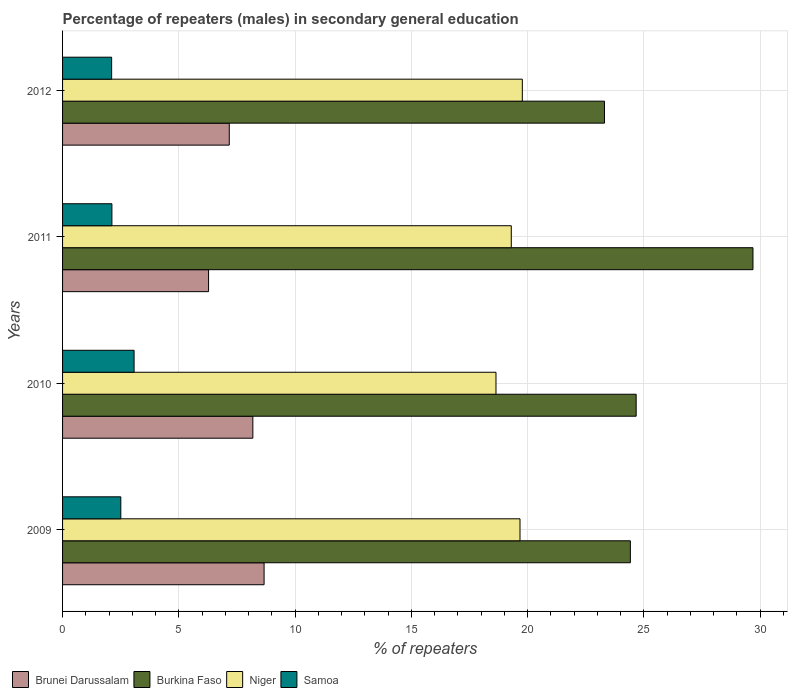Are the number of bars per tick equal to the number of legend labels?
Your response must be concise. Yes. How many bars are there on the 3rd tick from the top?
Ensure brevity in your answer.  4. What is the percentage of male repeaters in Brunei Darussalam in 2010?
Your answer should be compact. 8.18. Across all years, what is the maximum percentage of male repeaters in Brunei Darussalam?
Offer a terse response. 8.67. Across all years, what is the minimum percentage of male repeaters in Niger?
Offer a very short reply. 18.64. In which year was the percentage of male repeaters in Niger minimum?
Offer a terse response. 2010. What is the total percentage of male repeaters in Burkina Faso in the graph?
Give a very brief answer. 102.08. What is the difference between the percentage of male repeaters in Burkina Faso in 2011 and that in 2012?
Offer a very short reply. 6.39. What is the difference between the percentage of male repeaters in Brunei Darussalam in 2011 and the percentage of male repeaters in Burkina Faso in 2012?
Offer a terse response. -17.03. What is the average percentage of male repeaters in Brunei Darussalam per year?
Provide a succinct answer. 7.57. In the year 2009, what is the difference between the percentage of male repeaters in Samoa and percentage of male repeaters in Burkina Faso?
Your answer should be compact. -21.91. What is the ratio of the percentage of male repeaters in Brunei Darussalam in 2010 to that in 2012?
Your answer should be very brief. 1.14. Is the percentage of male repeaters in Burkina Faso in 2009 less than that in 2012?
Provide a succinct answer. No. Is the difference between the percentage of male repeaters in Samoa in 2009 and 2011 greater than the difference between the percentage of male repeaters in Burkina Faso in 2009 and 2011?
Your answer should be very brief. Yes. What is the difference between the highest and the second highest percentage of male repeaters in Niger?
Ensure brevity in your answer.  0.1. What is the difference between the highest and the lowest percentage of male repeaters in Niger?
Provide a succinct answer. 1.13. What does the 2nd bar from the top in 2012 represents?
Give a very brief answer. Niger. What does the 4th bar from the bottom in 2010 represents?
Offer a terse response. Samoa. Is it the case that in every year, the sum of the percentage of male repeaters in Burkina Faso and percentage of male repeaters in Samoa is greater than the percentage of male repeaters in Niger?
Offer a very short reply. Yes. How many bars are there?
Your answer should be very brief. 16. Are all the bars in the graph horizontal?
Provide a succinct answer. Yes. How many years are there in the graph?
Provide a succinct answer. 4. What is the difference between two consecutive major ticks on the X-axis?
Make the answer very short. 5. Does the graph contain any zero values?
Keep it short and to the point. No. Does the graph contain grids?
Ensure brevity in your answer.  Yes. How many legend labels are there?
Offer a very short reply. 4. What is the title of the graph?
Offer a very short reply. Percentage of repeaters (males) in secondary general education. What is the label or title of the X-axis?
Give a very brief answer. % of repeaters. What is the % of repeaters of Brunei Darussalam in 2009?
Offer a very short reply. 8.67. What is the % of repeaters in Burkina Faso in 2009?
Your response must be concise. 24.42. What is the % of repeaters in Niger in 2009?
Your answer should be very brief. 19.67. What is the % of repeaters of Samoa in 2009?
Your answer should be very brief. 2.51. What is the % of repeaters of Brunei Darussalam in 2010?
Keep it short and to the point. 8.18. What is the % of repeaters of Burkina Faso in 2010?
Ensure brevity in your answer.  24.67. What is the % of repeaters of Niger in 2010?
Make the answer very short. 18.64. What is the % of repeaters of Samoa in 2010?
Your response must be concise. 3.08. What is the % of repeaters in Brunei Darussalam in 2011?
Ensure brevity in your answer.  6.28. What is the % of repeaters in Burkina Faso in 2011?
Provide a succinct answer. 29.69. What is the % of repeaters in Niger in 2011?
Your answer should be compact. 19.3. What is the % of repeaters of Samoa in 2011?
Your answer should be compact. 2.12. What is the % of repeaters in Brunei Darussalam in 2012?
Your response must be concise. 7.17. What is the % of repeaters in Burkina Faso in 2012?
Provide a succinct answer. 23.3. What is the % of repeaters of Niger in 2012?
Make the answer very short. 19.77. What is the % of repeaters of Samoa in 2012?
Your answer should be very brief. 2.11. Across all years, what is the maximum % of repeaters in Brunei Darussalam?
Keep it short and to the point. 8.67. Across all years, what is the maximum % of repeaters in Burkina Faso?
Provide a succinct answer. 29.69. Across all years, what is the maximum % of repeaters in Niger?
Your response must be concise. 19.77. Across all years, what is the maximum % of repeaters in Samoa?
Offer a very short reply. 3.08. Across all years, what is the minimum % of repeaters of Brunei Darussalam?
Keep it short and to the point. 6.28. Across all years, what is the minimum % of repeaters of Burkina Faso?
Your response must be concise. 23.3. Across all years, what is the minimum % of repeaters of Niger?
Your answer should be very brief. 18.64. Across all years, what is the minimum % of repeaters in Samoa?
Offer a terse response. 2.11. What is the total % of repeaters of Brunei Darussalam in the graph?
Your answer should be very brief. 30.3. What is the total % of repeaters of Burkina Faso in the graph?
Your answer should be compact. 102.08. What is the total % of repeaters in Niger in the graph?
Give a very brief answer. 77.38. What is the total % of repeaters in Samoa in the graph?
Your answer should be compact. 9.81. What is the difference between the % of repeaters in Brunei Darussalam in 2009 and that in 2010?
Ensure brevity in your answer.  0.48. What is the difference between the % of repeaters in Burkina Faso in 2009 and that in 2010?
Give a very brief answer. -0.25. What is the difference between the % of repeaters of Niger in 2009 and that in 2010?
Your answer should be compact. 1.03. What is the difference between the % of repeaters in Samoa in 2009 and that in 2010?
Give a very brief answer. -0.57. What is the difference between the % of repeaters of Brunei Darussalam in 2009 and that in 2011?
Keep it short and to the point. 2.39. What is the difference between the % of repeaters of Burkina Faso in 2009 and that in 2011?
Make the answer very short. -5.27. What is the difference between the % of repeaters in Samoa in 2009 and that in 2011?
Offer a terse response. 0.38. What is the difference between the % of repeaters of Brunei Darussalam in 2009 and that in 2012?
Make the answer very short. 1.5. What is the difference between the % of repeaters of Burkina Faso in 2009 and that in 2012?
Offer a very short reply. 1.11. What is the difference between the % of repeaters of Niger in 2009 and that in 2012?
Provide a short and direct response. -0.1. What is the difference between the % of repeaters in Samoa in 2009 and that in 2012?
Your answer should be compact. 0.39. What is the difference between the % of repeaters of Brunei Darussalam in 2010 and that in 2011?
Keep it short and to the point. 1.9. What is the difference between the % of repeaters of Burkina Faso in 2010 and that in 2011?
Your answer should be compact. -5.02. What is the difference between the % of repeaters of Niger in 2010 and that in 2011?
Your answer should be very brief. -0.66. What is the difference between the % of repeaters in Samoa in 2010 and that in 2011?
Offer a very short reply. 0.95. What is the difference between the % of repeaters in Brunei Darussalam in 2010 and that in 2012?
Make the answer very short. 1.01. What is the difference between the % of repeaters in Burkina Faso in 2010 and that in 2012?
Offer a terse response. 1.36. What is the difference between the % of repeaters of Niger in 2010 and that in 2012?
Give a very brief answer. -1.13. What is the difference between the % of repeaters of Samoa in 2010 and that in 2012?
Offer a very short reply. 0.96. What is the difference between the % of repeaters in Brunei Darussalam in 2011 and that in 2012?
Your response must be concise. -0.89. What is the difference between the % of repeaters of Burkina Faso in 2011 and that in 2012?
Ensure brevity in your answer.  6.39. What is the difference between the % of repeaters of Niger in 2011 and that in 2012?
Offer a very short reply. -0.47. What is the difference between the % of repeaters in Samoa in 2011 and that in 2012?
Your answer should be compact. 0.01. What is the difference between the % of repeaters in Brunei Darussalam in 2009 and the % of repeaters in Burkina Faso in 2010?
Offer a terse response. -16. What is the difference between the % of repeaters of Brunei Darussalam in 2009 and the % of repeaters of Niger in 2010?
Provide a short and direct response. -9.97. What is the difference between the % of repeaters in Brunei Darussalam in 2009 and the % of repeaters in Samoa in 2010?
Your answer should be very brief. 5.59. What is the difference between the % of repeaters of Burkina Faso in 2009 and the % of repeaters of Niger in 2010?
Offer a very short reply. 5.78. What is the difference between the % of repeaters of Burkina Faso in 2009 and the % of repeaters of Samoa in 2010?
Keep it short and to the point. 21.34. What is the difference between the % of repeaters of Niger in 2009 and the % of repeaters of Samoa in 2010?
Give a very brief answer. 16.6. What is the difference between the % of repeaters of Brunei Darussalam in 2009 and the % of repeaters of Burkina Faso in 2011?
Give a very brief answer. -21.02. What is the difference between the % of repeaters in Brunei Darussalam in 2009 and the % of repeaters in Niger in 2011?
Offer a very short reply. -10.63. What is the difference between the % of repeaters of Brunei Darussalam in 2009 and the % of repeaters of Samoa in 2011?
Make the answer very short. 6.54. What is the difference between the % of repeaters in Burkina Faso in 2009 and the % of repeaters in Niger in 2011?
Provide a short and direct response. 5.12. What is the difference between the % of repeaters of Burkina Faso in 2009 and the % of repeaters of Samoa in 2011?
Offer a very short reply. 22.3. What is the difference between the % of repeaters of Niger in 2009 and the % of repeaters of Samoa in 2011?
Offer a terse response. 17.55. What is the difference between the % of repeaters in Brunei Darussalam in 2009 and the % of repeaters in Burkina Faso in 2012?
Ensure brevity in your answer.  -14.64. What is the difference between the % of repeaters of Brunei Darussalam in 2009 and the % of repeaters of Niger in 2012?
Your answer should be very brief. -11.11. What is the difference between the % of repeaters of Brunei Darussalam in 2009 and the % of repeaters of Samoa in 2012?
Your answer should be compact. 6.56. What is the difference between the % of repeaters in Burkina Faso in 2009 and the % of repeaters in Niger in 2012?
Provide a short and direct response. 4.65. What is the difference between the % of repeaters in Burkina Faso in 2009 and the % of repeaters in Samoa in 2012?
Offer a very short reply. 22.31. What is the difference between the % of repeaters of Niger in 2009 and the % of repeaters of Samoa in 2012?
Offer a terse response. 17.56. What is the difference between the % of repeaters in Brunei Darussalam in 2010 and the % of repeaters in Burkina Faso in 2011?
Give a very brief answer. -21.51. What is the difference between the % of repeaters in Brunei Darussalam in 2010 and the % of repeaters in Niger in 2011?
Keep it short and to the point. -11.11. What is the difference between the % of repeaters of Brunei Darussalam in 2010 and the % of repeaters of Samoa in 2011?
Your response must be concise. 6.06. What is the difference between the % of repeaters of Burkina Faso in 2010 and the % of repeaters of Niger in 2011?
Keep it short and to the point. 5.37. What is the difference between the % of repeaters of Burkina Faso in 2010 and the % of repeaters of Samoa in 2011?
Your answer should be very brief. 22.55. What is the difference between the % of repeaters of Niger in 2010 and the % of repeaters of Samoa in 2011?
Your answer should be compact. 16.52. What is the difference between the % of repeaters of Brunei Darussalam in 2010 and the % of repeaters of Burkina Faso in 2012?
Make the answer very short. -15.12. What is the difference between the % of repeaters in Brunei Darussalam in 2010 and the % of repeaters in Niger in 2012?
Provide a succinct answer. -11.59. What is the difference between the % of repeaters of Brunei Darussalam in 2010 and the % of repeaters of Samoa in 2012?
Your answer should be compact. 6.07. What is the difference between the % of repeaters in Burkina Faso in 2010 and the % of repeaters in Niger in 2012?
Provide a succinct answer. 4.9. What is the difference between the % of repeaters of Burkina Faso in 2010 and the % of repeaters of Samoa in 2012?
Ensure brevity in your answer.  22.56. What is the difference between the % of repeaters of Niger in 2010 and the % of repeaters of Samoa in 2012?
Offer a very short reply. 16.53. What is the difference between the % of repeaters of Brunei Darussalam in 2011 and the % of repeaters of Burkina Faso in 2012?
Provide a short and direct response. -17.03. What is the difference between the % of repeaters in Brunei Darussalam in 2011 and the % of repeaters in Niger in 2012?
Keep it short and to the point. -13.49. What is the difference between the % of repeaters of Brunei Darussalam in 2011 and the % of repeaters of Samoa in 2012?
Provide a short and direct response. 4.17. What is the difference between the % of repeaters of Burkina Faso in 2011 and the % of repeaters of Niger in 2012?
Make the answer very short. 9.92. What is the difference between the % of repeaters of Burkina Faso in 2011 and the % of repeaters of Samoa in 2012?
Your answer should be compact. 27.58. What is the difference between the % of repeaters of Niger in 2011 and the % of repeaters of Samoa in 2012?
Your answer should be compact. 17.19. What is the average % of repeaters in Brunei Darussalam per year?
Offer a terse response. 7.57. What is the average % of repeaters in Burkina Faso per year?
Provide a short and direct response. 25.52. What is the average % of repeaters in Niger per year?
Give a very brief answer. 19.35. What is the average % of repeaters of Samoa per year?
Ensure brevity in your answer.  2.45. In the year 2009, what is the difference between the % of repeaters of Brunei Darussalam and % of repeaters of Burkina Faso?
Ensure brevity in your answer.  -15.75. In the year 2009, what is the difference between the % of repeaters in Brunei Darussalam and % of repeaters in Niger?
Keep it short and to the point. -11.01. In the year 2009, what is the difference between the % of repeaters in Brunei Darussalam and % of repeaters in Samoa?
Make the answer very short. 6.16. In the year 2009, what is the difference between the % of repeaters of Burkina Faso and % of repeaters of Niger?
Your answer should be compact. 4.75. In the year 2009, what is the difference between the % of repeaters in Burkina Faso and % of repeaters in Samoa?
Make the answer very short. 21.91. In the year 2009, what is the difference between the % of repeaters of Niger and % of repeaters of Samoa?
Offer a terse response. 17.17. In the year 2010, what is the difference between the % of repeaters of Brunei Darussalam and % of repeaters of Burkina Faso?
Provide a succinct answer. -16.48. In the year 2010, what is the difference between the % of repeaters of Brunei Darussalam and % of repeaters of Niger?
Give a very brief answer. -10.46. In the year 2010, what is the difference between the % of repeaters of Brunei Darussalam and % of repeaters of Samoa?
Make the answer very short. 5.11. In the year 2010, what is the difference between the % of repeaters in Burkina Faso and % of repeaters in Niger?
Your answer should be compact. 6.03. In the year 2010, what is the difference between the % of repeaters in Burkina Faso and % of repeaters in Samoa?
Offer a very short reply. 21.59. In the year 2010, what is the difference between the % of repeaters in Niger and % of repeaters in Samoa?
Give a very brief answer. 15.56. In the year 2011, what is the difference between the % of repeaters of Brunei Darussalam and % of repeaters of Burkina Faso?
Your answer should be compact. -23.41. In the year 2011, what is the difference between the % of repeaters in Brunei Darussalam and % of repeaters in Niger?
Give a very brief answer. -13.02. In the year 2011, what is the difference between the % of repeaters in Brunei Darussalam and % of repeaters in Samoa?
Keep it short and to the point. 4.16. In the year 2011, what is the difference between the % of repeaters in Burkina Faso and % of repeaters in Niger?
Your response must be concise. 10.39. In the year 2011, what is the difference between the % of repeaters in Burkina Faso and % of repeaters in Samoa?
Offer a terse response. 27.57. In the year 2011, what is the difference between the % of repeaters of Niger and % of repeaters of Samoa?
Your response must be concise. 17.18. In the year 2012, what is the difference between the % of repeaters in Brunei Darussalam and % of repeaters in Burkina Faso?
Your answer should be compact. -16.14. In the year 2012, what is the difference between the % of repeaters of Brunei Darussalam and % of repeaters of Niger?
Offer a terse response. -12.6. In the year 2012, what is the difference between the % of repeaters in Brunei Darussalam and % of repeaters in Samoa?
Keep it short and to the point. 5.06. In the year 2012, what is the difference between the % of repeaters in Burkina Faso and % of repeaters in Niger?
Offer a very short reply. 3.53. In the year 2012, what is the difference between the % of repeaters of Burkina Faso and % of repeaters of Samoa?
Provide a succinct answer. 21.19. In the year 2012, what is the difference between the % of repeaters in Niger and % of repeaters in Samoa?
Ensure brevity in your answer.  17.66. What is the ratio of the % of repeaters of Brunei Darussalam in 2009 to that in 2010?
Provide a short and direct response. 1.06. What is the ratio of the % of repeaters of Niger in 2009 to that in 2010?
Your response must be concise. 1.06. What is the ratio of the % of repeaters in Samoa in 2009 to that in 2010?
Your response must be concise. 0.81. What is the ratio of the % of repeaters of Brunei Darussalam in 2009 to that in 2011?
Offer a terse response. 1.38. What is the ratio of the % of repeaters in Burkina Faso in 2009 to that in 2011?
Provide a short and direct response. 0.82. What is the ratio of the % of repeaters of Niger in 2009 to that in 2011?
Offer a very short reply. 1.02. What is the ratio of the % of repeaters of Samoa in 2009 to that in 2011?
Your answer should be compact. 1.18. What is the ratio of the % of repeaters of Brunei Darussalam in 2009 to that in 2012?
Keep it short and to the point. 1.21. What is the ratio of the % of repeaters of Burkina Faso in 2009 to that in 2012?
Offer a terse response. 1.05. What is the ratio of the % of repeaters in Samoa in 2009 to that in 2012?
Your answer should be compact. 1.19. What is the ratio of the % of repeaters in Brunei Darussalam in 2010 to that in 2011?
Your answer should be compact. 1.3. What is the ratio of the % of repeaters of Burkina Faso in 2010 to that in 2011?
Your response must be concise. 0.83. What is the ratio of the % of repeaters of Niger in 2010 to that in 2011?
Provide a short and direct response. 0.97. What is the ratio of the % of repeaters of Samoa in 2010 to that in 2011?
Your answer should be compact. 1.45. What is the ratio of the % of repeaters in Brunei Darussalam in 2010 to that in 2012?
Ensure brevity in your answer.  1.14. What is the ratio of the % of repeaters in Burkina Faso in 2010 to that in 2012?
Keep it short and to the point. 1.06. What is the ratio of the % of repeaters of Niger in 2010 to that in 2012?
Keep it short and to the point. 0.94. What is the ratio of the % of repeaters in Samoa in 2010 to that in 2012?
Make the answer very short. 1.46. What is the ratio of the % of repeaters of Brunei Darussalam in 2011 to that in 2012?
Your answer should be compact. 0.88. What is the ratio of the % of repeaters of Burkina Faso in 2011 to that in 2012?
Ensure brevity in your answer.  1.27. What is the ratio of the % of repeaters of Niger in 2011 to that in 2012?
Offer a terse response. 0.98. What is the difference between the highest and the second highest % of repeaters in Brunei Darussalam?
Your answer should be very brief. 0.48. What is the difference between the highest and the second highest % of repeaters of Burkina Faso?
Ensure brevity in your answer.  5.02. What is the difference between the highest and the second highest % of repeaters in Niger?
Provide a short and direct response. 0.1. What is the difference between the highest and the second highest % of repeaters of Samoa?
Offer a very short reply. 0.57. What is the difference between the highest and the lowest % of repeaters in Brunei Darussalam?
Provide a short and direct response. 2.39. What is the difference between the highest and the lowest % of repeaters of Burkina Faso?
Keep it short and to the point. 6.39. What is the difference between the highest and the lowest % of repeaters in Niger?
Your response must be concise. 1.13. What is the difference between the highest and the lowest % of repeaters in Samoa?
Ensure brevity in your answer.  0.96. 